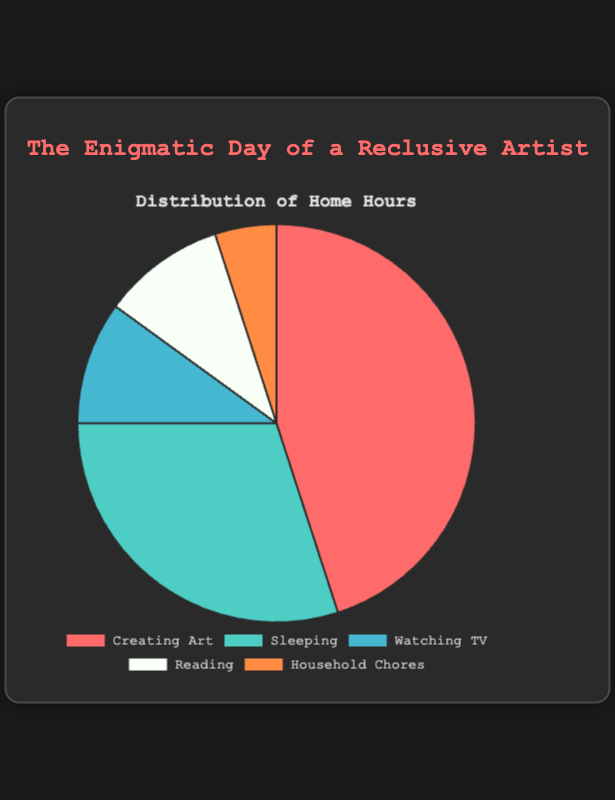Which activity takes up the most hours in the artist's daily routine? From the pie chart, the slice representing "Creating Art" is the largest, indicating it has the highest value compared to other activities
Answer: Creating Art Which activities take up equal amounts of time? By observing the pie chart, both "Watching TV" and "Reading" have equal-sized slices, indicating they take up the same amount of time
Answer: Watching TV and Reading How many more hours does the artist spend Creating Art compared to Sleeping? The chart shows 45 hours for "Creating Art" and 30 hours for "Sleeping". Subtracting these gives 45 - 30 = 15 additional hours spent on Creating Art
Answer: 15 What is the total number of hours spent on activities other than Creating Art? The chart slices show 30 hours for Sleeping, 10 for Watching TV, 10 for Reading, and 5 for Household Chores. Adding these gives 30 + 10 + 10 + 5 = 55 hours
Answer: 55 What proportion of the artist's time is spent on Household Chores? The chart indicates Household Chores are 5 hours out of a total of 100 hours. The proportion is 5/100 = 5%
Answer: 5% How much more time does the artist spend on Sleeping than Watching TV? The pie chart shows 30 hours for Sleeping and 10 hours for Watching TV. The difference is 30 - 10 = 20 more hours on Sleeping
Answer: 20 Arrange the activities in descending order of hours spent. From the pie chart, the activities can be arranged as follows: Creating Art (45), Sleeping (30), Watching TV (10), Reading (10), Household Chores (5)
Answer: Creating Art, Sleeping, Watching TV, Reading, Household Chores What is the average number of hours spent on Watching TV, Reading, and Household Chores? The chart shows 10 hours for Watching TV, 10 hours for Reading, and 5 hours for Household Chores. Adding these is 10 + 10 + 5 = 25; the average is 25/3 ≈ 8.33 hours
Answer: 8.33 Which activity occupies the smallest slice of the pie chart? By looking at the pie chart, the smallest slice is for "Household Chores"
Answer: Household Chores 